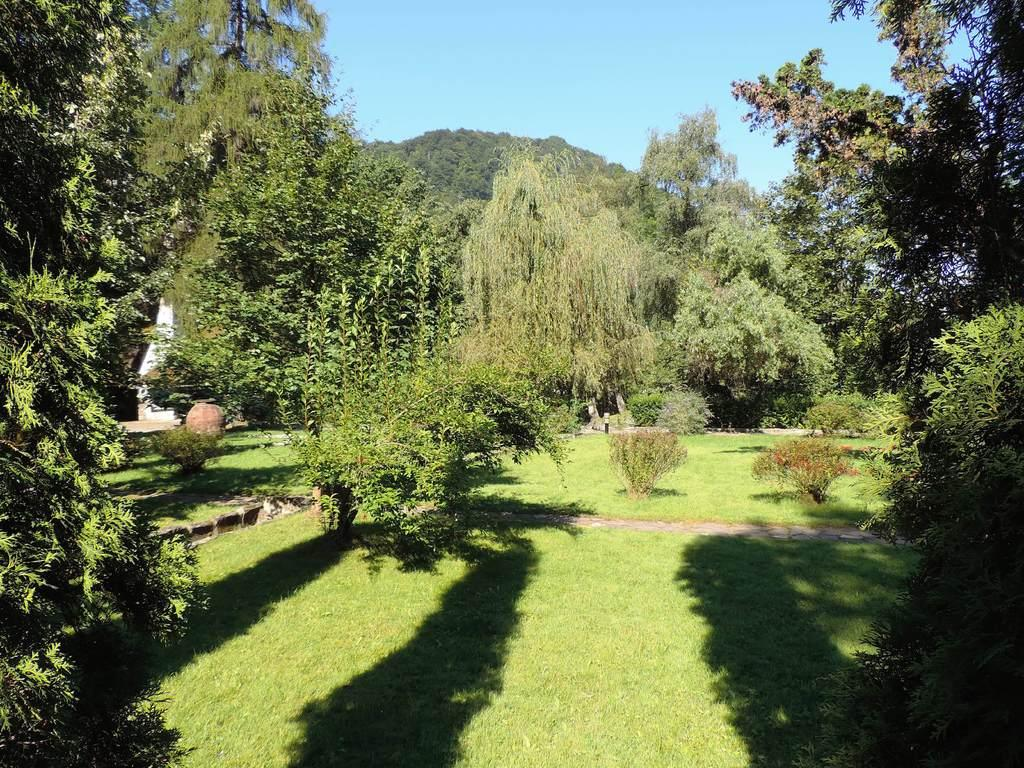What type of vegetation can be seen in the image? There are many trees and some plants in the image. Can you describe the mountain in the image? The mountain in the image has trees on it. What is visible at the top of the image? The sky is visible at the top of the image. What type of ground cover is present at the bottom of the image? Grass is present at the bottom of the image. What title does the achiever hold in the image? There is no achiever or title present in the image; it features trees, plants, a mountain, and grass. 